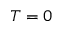<formula> <loc_0><loc_0><loc_500><loc_500>T = 0</formula> 